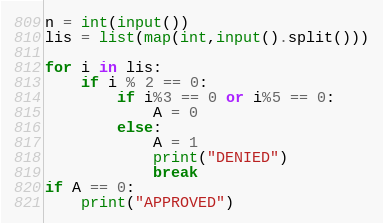Convert code to text. <code><loc_0><loc_0><loc_500><loc_500><_Python_>n = int(input())
lis = list(map(int,input().split()))

for i in lis:
    if i % 2 == 0:
        if i%3 == 0 or i%5 == 0:
            A = 0
        else:
            A = 1
            print("DENIED")
            break
if A == 0:
    print("APPROVED")
</code> 